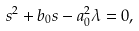<formula> <loc_0><loc_0><loc_500><loc_500>s ^ { 2 } + b _ { 0 } s - a _ { 0 } ^ { 2 } \lambda = 0 ,</formula> 